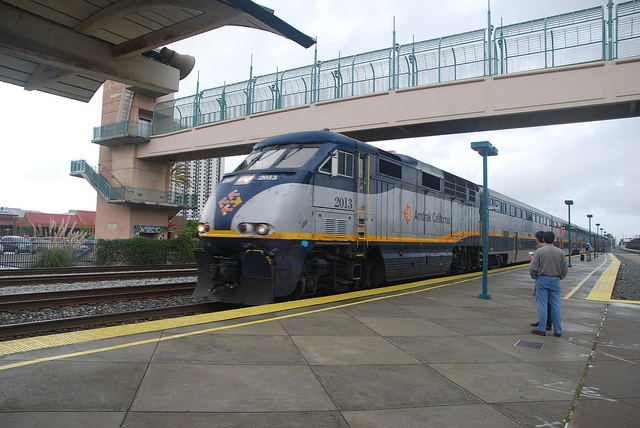Describe the objects in this image and their specific colors. I can see train in black, gray, and darkgray tones, people in black, gray, and blue tones, car in black, gray, blue, and darkgray tones, people in black, gray, and brown tones, and people in black, gray, and blue tones in this image. 